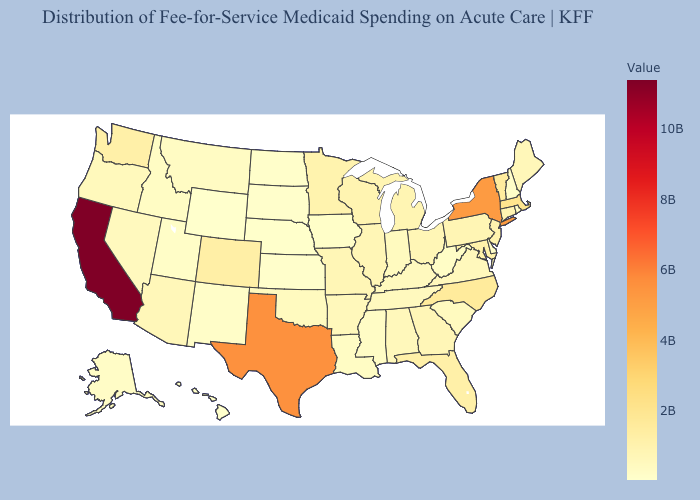Which states have the highest value in the USA?
Answer briefly. California. Among the states that border Kentucky , does Virginia have the highest value?
Give a very brief answer. No. Among the states that border South Dakota , does Nebraska have the highest value?
Be succinct. No. Among the states that border Wyoming , which have the highest value?
Give a very brief answer. Colorado. Among the states that border Mississippi , which have the highest value?
Quick response, please. Arkansas. 